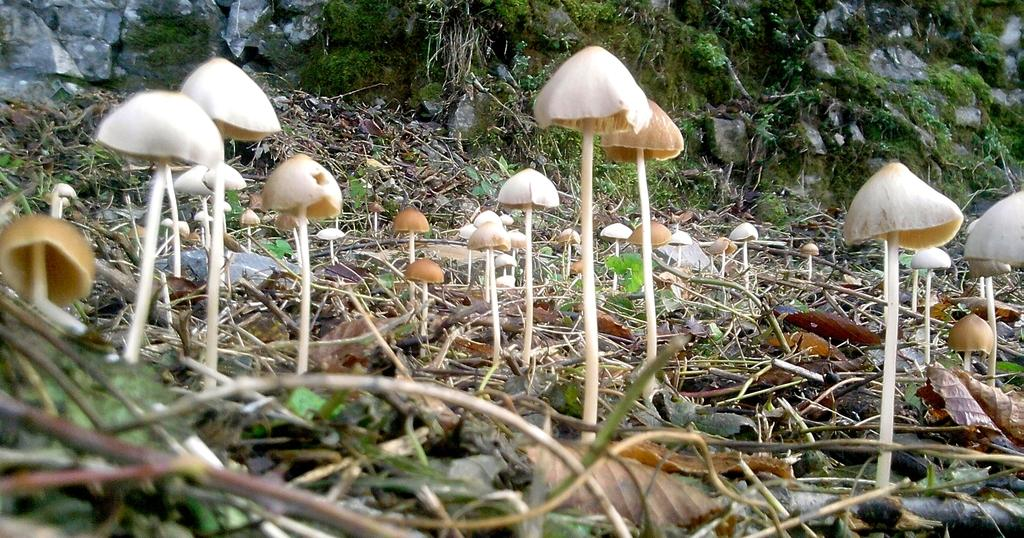What type of living organisms can be seen in the image? Plants and mushrooms can be seen in the image. Can you describe the colors of the mushrooms? The mushrooms have cream, white, and brown colors. What is visible in the background of the image? There is a rocky surface in the background of the image, and grass is present on the rocky surface. How many bears can be seen interacting with the mushrooms in the image? There are no bears present in the image; it features plants and mushrooms. What type of curve is visible in the image? There is no curve visible in the image; it primarily consists of plants, mushrooms, and a rocky surface with grass. 